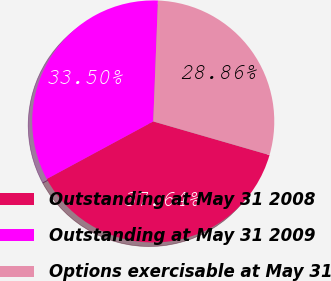<chart> <loc_0><loc_0><loc_500><loc_500><pie_chart><fcel>Outstanding at May 31 2008<fcel>Outstanding at May 31 2009<fcel>Options exercisable at May 31<nl><fcel>37.64%<fcel>33.5%<fcel>28.86%<nl></chart> 